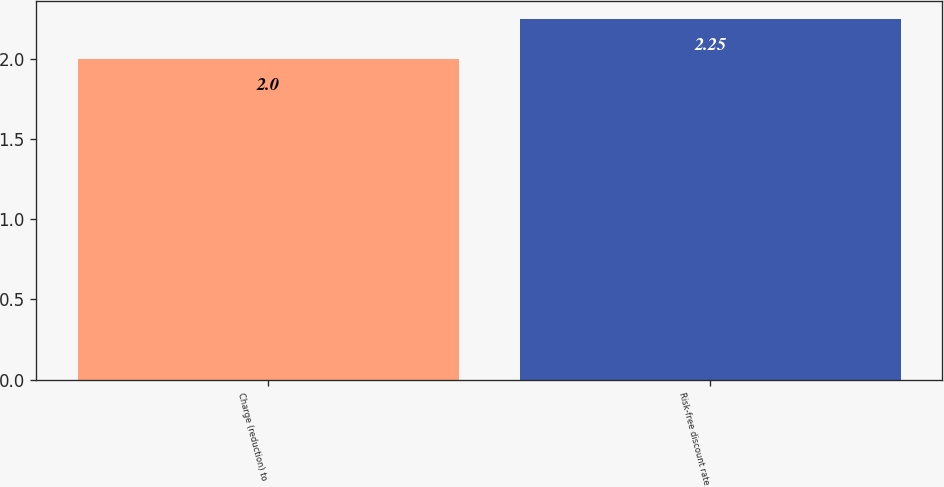Convert chart. <chart><loc_0><loc_0><loc_500><loc_500><bar_chart><fcel>Charge (reduction) to<fcel>Risk-free discount rate<nl><fcel>2<fcel>2.25<nl></chart> 